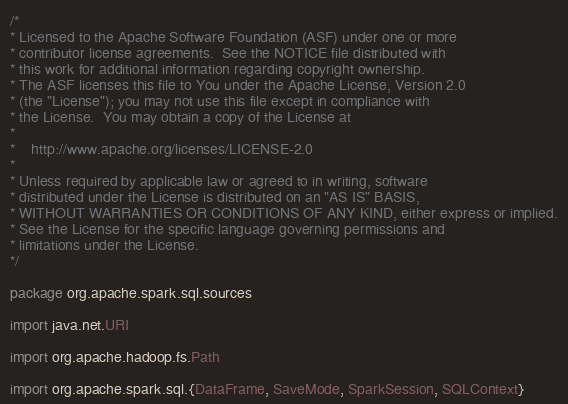Convert code to text. <code><loc_0><loc_0><loc_500><loc_500><_Scala_>/*
* Licensed to the Apache Software Foundation (ASF) under one or more
* contributor license agreements.  See the NOTICE file distributed with
* this work for additional information regarding copyright ownership.
* The ASF licenses this file to You under the Apache License, Version 2.0
* (the "License"); you may not use this file except in compliance with
* the License.  You may obtain a copy of the License at
*
*    http://www.apache.org/licenses/LICENSE-2.0
*
* Unless required by applicable law or agreed to in writing, software
* distributed under the License is distributed on an "AS IS" BASIS,
* WITHOUT WARRANTIES OR CONDITIONS OF ANY KIND, either express or implied.
* See the License for the specific language governing permissions and
* limitations under the License.
*/

package org.apache.spark.sql.sources

import java.net.URI

import org.apache.hadoop.fs.Path

import org.apache.spark.sql.{DataFrame, SaveMode, SparkSession, SQLContext}</code> 